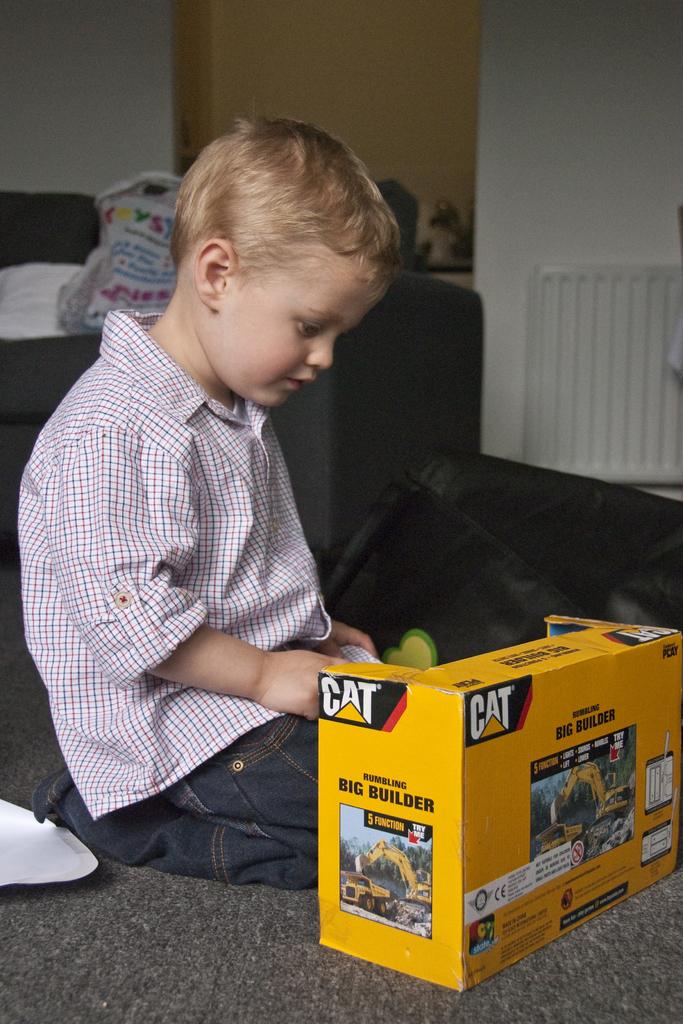What is the brand of the toy that the boy is looking at?
Your response must be concise. Cat. What is the name of this construction vehicle?
Offer a terse response. Cat. 